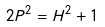<formula> <loc_0><loc_0><loc_500><loc_500>2 P ^ { 2 } = H ^ { 2 } + 1</formula> 